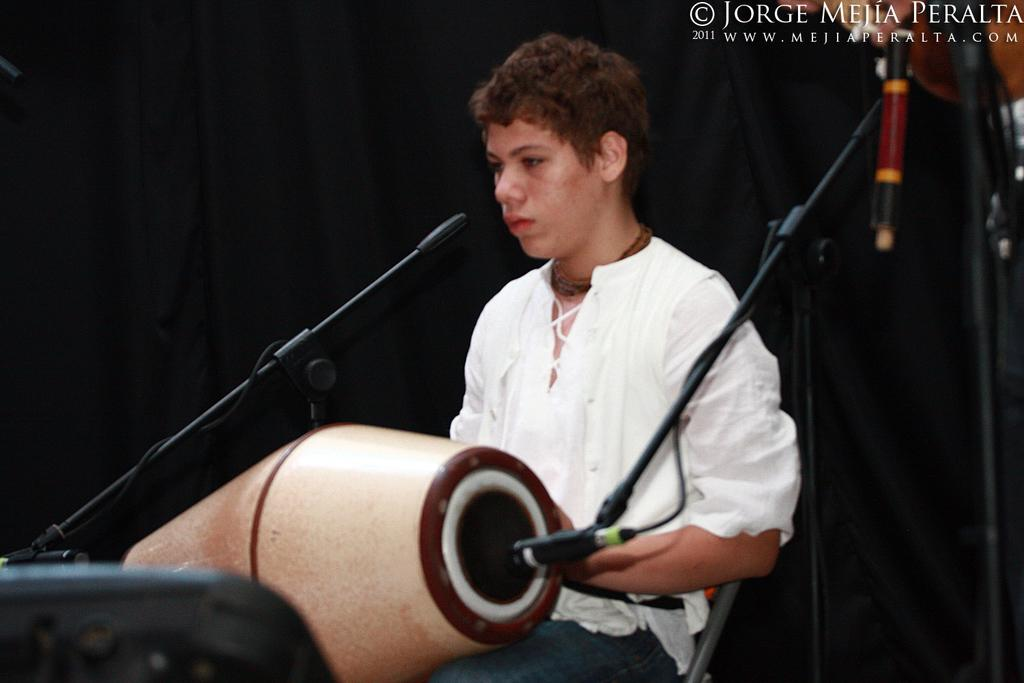What is the person in the image doing? The person is sitting on a chair in the image and has a drum on their lap. What object is present in the image that might be used for amplifying sound? There is a microphone in the image. What is the color of the background in the image? The background of the image is black. How many cacti are visible in the image? There are no cacti present in the image. What type of competition is the person participating in, as seen in the image? The image does not depict any competition; it simply shows a person sitting with a drum and a microphone. 